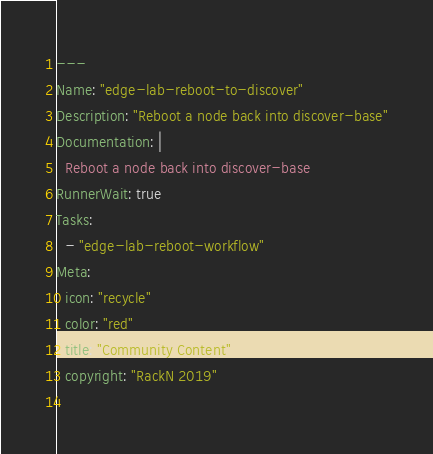<code> <loc_0><loc_0><loc_500><loc_500><_YAML_>---
Name: "edge-lab-reboot-to-discover"
Description: "Reboot a node back into discover-base"
Documentation: |
  Reboot a node back into discover-base
RunnerWait: true
Tasks:
  - "edge-lab-reboot-workflow"
Meta:
  icon: "recycle"
  color: "red"
  title: "Community Content"
  copyright: "RackN 2019"
  
</code> 